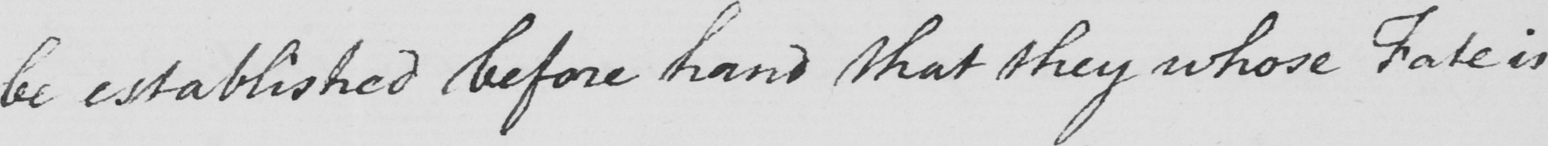What does this handwritten line say? be established before hand that they whose Fate is 